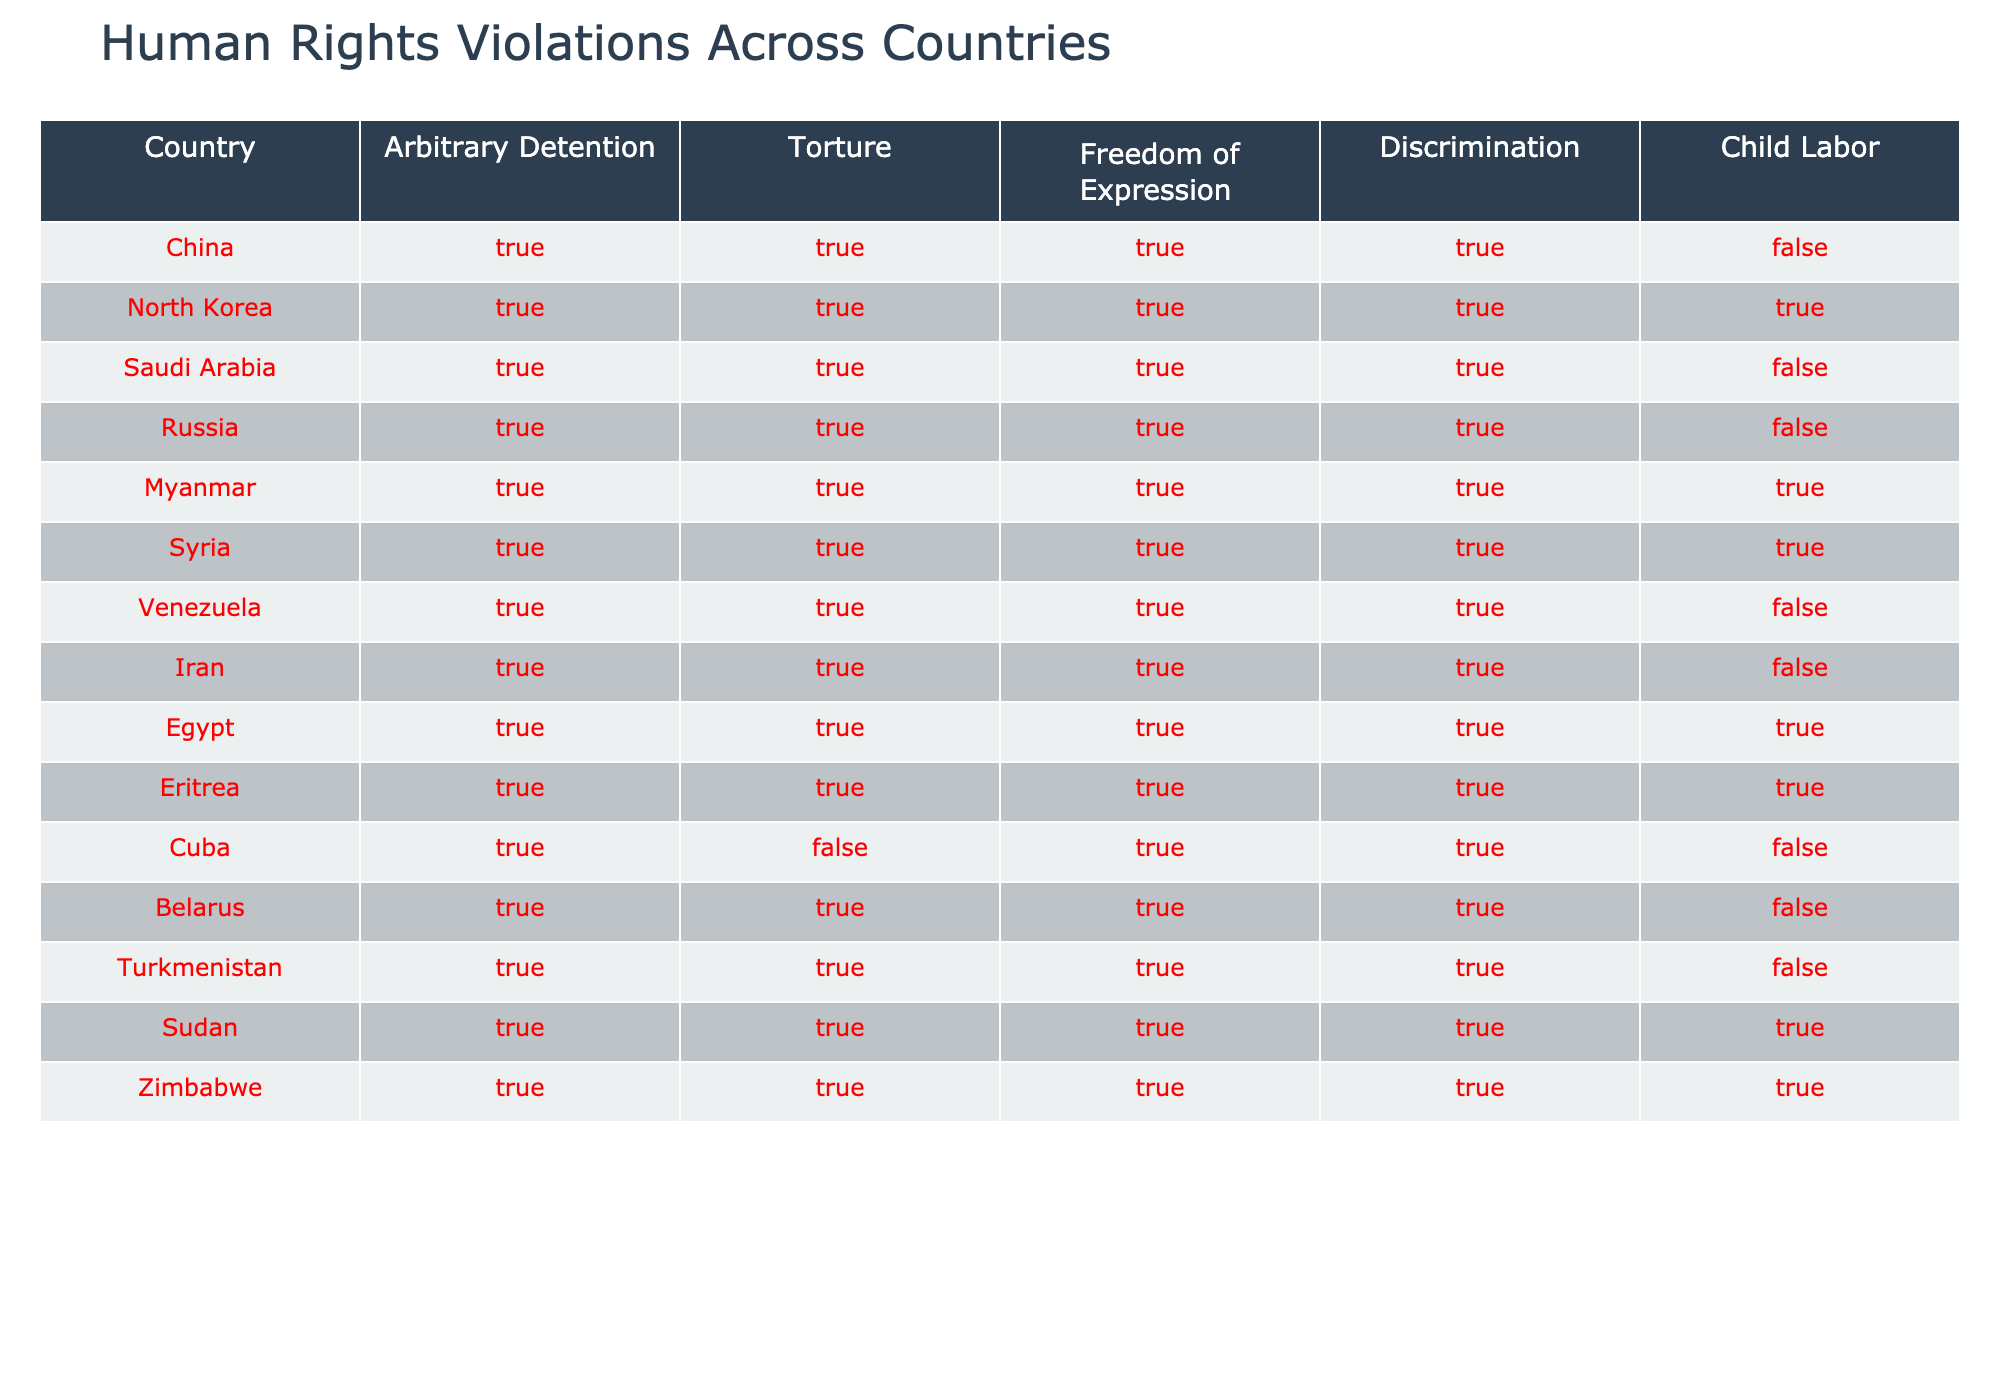What is the only country that does not have arbitrary detention or torture? By checking the table, I see that all countries listed have a "True" value under both the 'Arbitrary Detention' and 'Torture' columns. Therefore, there is no country where both conditions are not met.
Answer: None Which country has the highest number of reported human rights violations? To find this, I need to identify countries with "True" in all categories. 'North Korea', 'Syria', 'Iran', and 'Eritrea' have True across all violation categories (Arbitrary Detention, Torture, Freedom of Expression, Discrimination, and Child Labor). So, those countries have the highest number of violations.
Answer: North Korea, Syria, Iran, Eritrea Is there any country that engages in both arbitrary detention and child labor? I can look at the 'Arbitrary Detention' and 'Child Labor' columns. I see 'China', 'North Korea', 'Myanmar', 'Egypt', 'Eritrea', 'Sudan', and 'Zimbabwe' have "True" values under both categories. Hence, these countries engage in both.
Answer: Yes What is the total number of countries that have no reported child labor? I can count the countries with a "False" under the 'Child Labor' column. From the table, 'China', 'Saudi Arabia', 'Venezuela', and 'Iran' do not report child labor. Thus, the total is four.
Answer: Four Do more countries report torture or discrimination? I need to tally the number of countries with "True" in the 'Torture' column (all countries) and compare it to those in the 'Discrimination' column. Since all countries listed have "True" for both columns, the counts are equal.
Answer: Equal Which country has the least number of human rights violations based on the table? To determine the country with the fewest violations, I need to identify rows with the most "False" values. 'Cuba' has one "False" in 'Torture', making it the country with fewer violations relative to others.
Answer: Cuba Are there any countries where freedom of expression is guaranteed? Looking at the 'Freedom of Expression' column, I see that all countries except for 'Cuba' and 'Iran' have a "True". Hence, all countries listed, except these two ensure freedom of expression.
Answer: No What country exhibits all four forms of human rights violation? By examining the rows, I find that all countries but 'Cuba' and 'Iran' have "True" in the first four categories: 'Arbitrary Detention', 'Torture', 'Freedom of Expression', and 'Discrimination'. Thus, most countries exhibit these forms of violation.
Answer: Most countries 